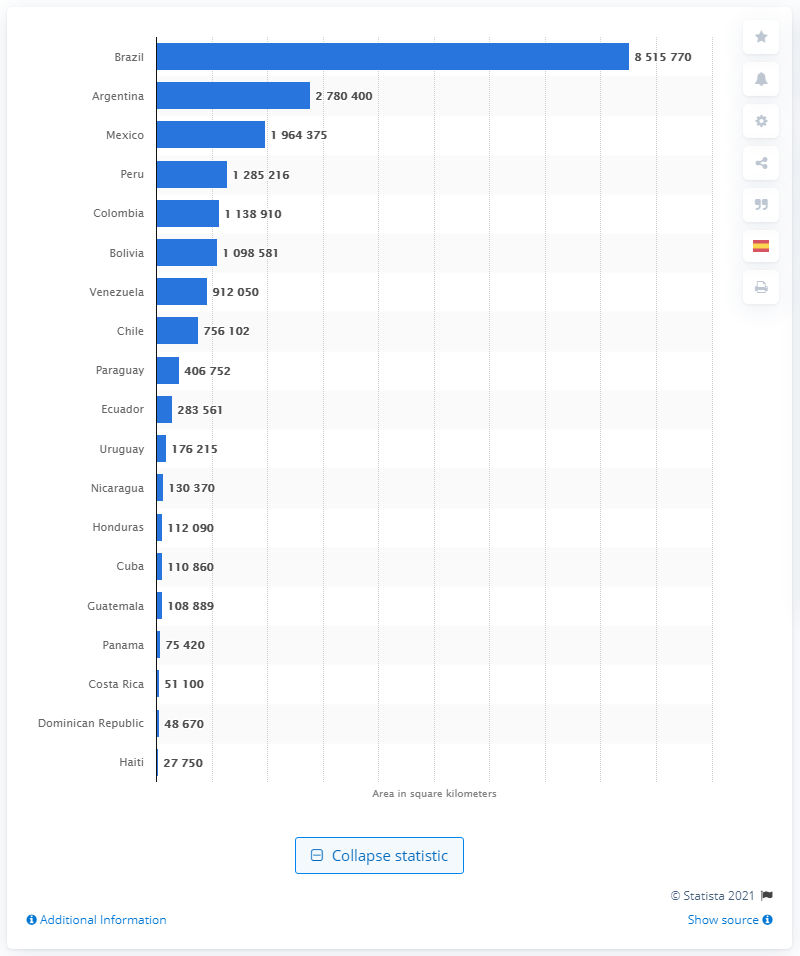How does Brazil's size compare to that of the other countries on the list? Brazil's size is remarkably larger than that of other countries on the list. For reference, Brazil's area is more than three times that of Mexico, the third-largest country in the chart. What implications might Brazil's large size have on its environment and economy? Brazil's vast landmass contributes to its diverse ecosystems, from the Amazon rainforest to the Pantanal wetlands. Economically, its size allows for significant agricultural production, natural resource exploitation, and varied industries, although it also poses challenges in terms of infrastructure and regional development. 